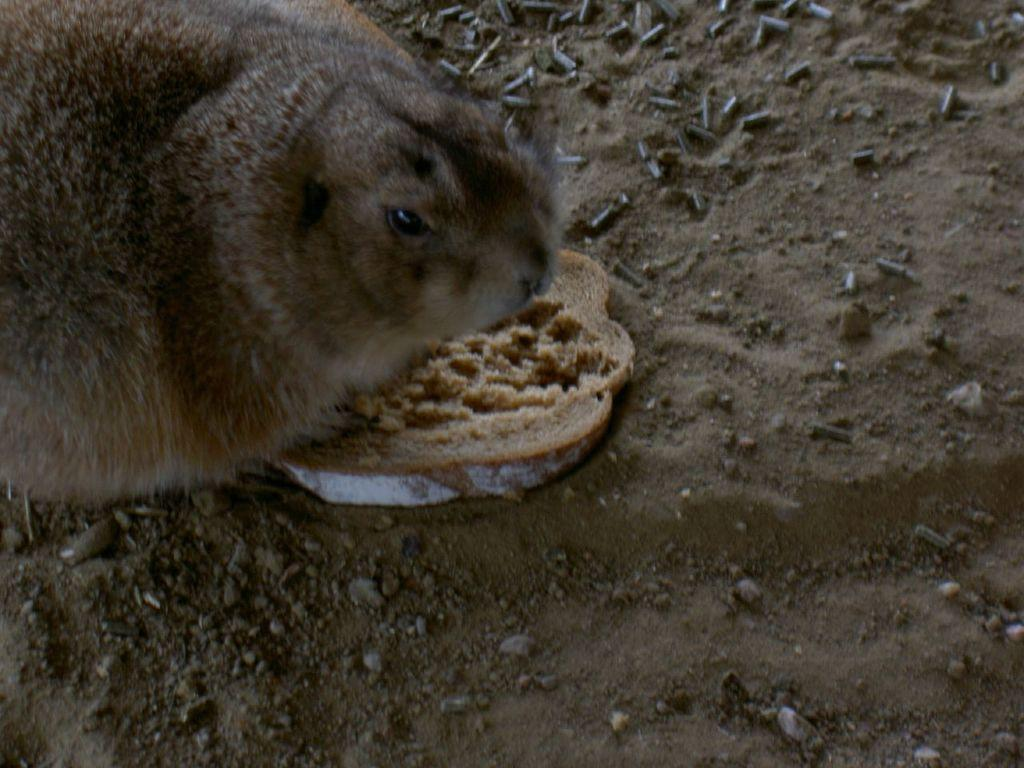What type of animal is in the image? There is an animal in the image, but the specific type cannot be determined from the provided facts. What food item is visible in the image? There is a bread slice in the image. What can be seen on the ground in the image? There are stones on the ground in the image. What type of structure can be seen in the background of the image? There is no structure visible in the background of the image. Is the animal in the image sleeping? The image does not provide any information about the animal's state, such as whether it is sleeping or not. 